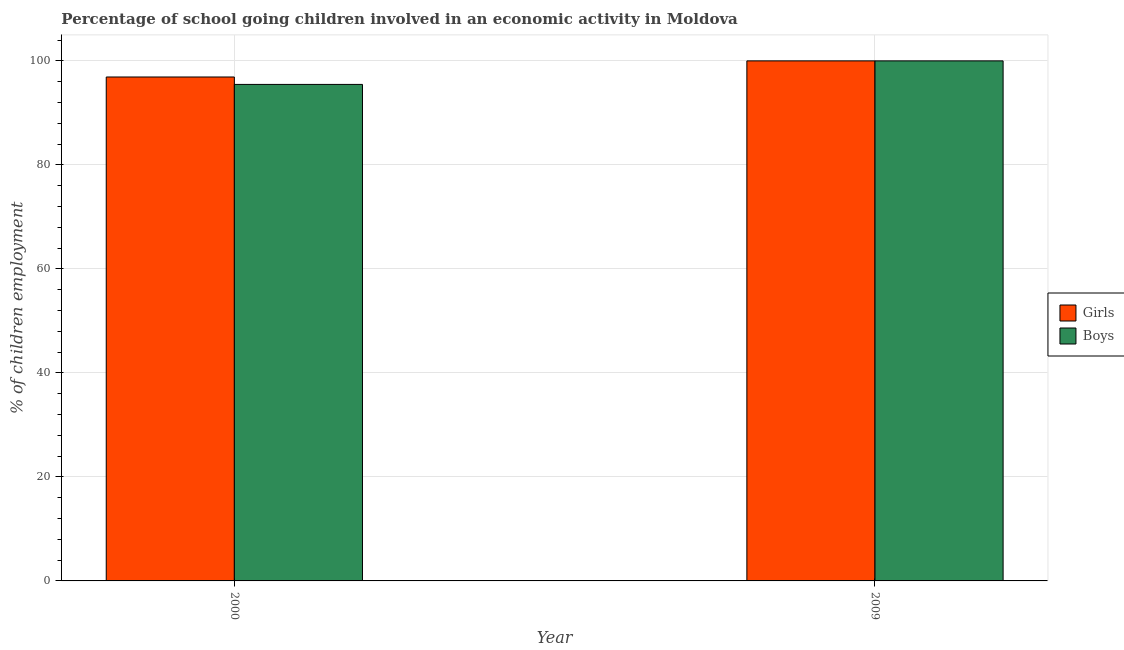How many groups of bars are there?
Make the answer very short. 2. Are the number of bars per tick equal to the number of legend labels?
Offer a very short reply. Yes. How many bars are there on the 1st tick from the left?
Your answer should be compact. 2. In how many cases, is the number of bars for a given year not equal to the number of legend labels?
Make the answer very short. 0. What is the percentage of school going boys in 2000?
Provide a succinct answer. 95.47. Across all years, what is the minimum percentage of school going boys?
Provide a succinct answer. 95.47. What is the total percentage of school going girls in the graph?
Keep it short and to the point. 196.9. What is the difference between the percentage of school going boys in 2000 and that in 2009?
Your answer should be very brief. -4.53. What is the difference between the percentage of school going girls in 2009 and the percentage of school going boys in 2000?
Your response must be concise. 3.1. What is the average percentage of school going girls per year?
Provide a short and direct response. 98.45. What is the ratio of the percentage of school going boys in 2000 to that in 2009?
Your answer should be very brief. 0.95. What does the 2nd bar from the left in 2000 represents?
Offer a very short reply. Boys. What does the 2nd bar from the right in 2000 represents?
Provide a short and direct response. Girls. Are all the bars in the graph horizontal?
Your answer should be very brief. No. What is the difference between two consecutive major ticks on the Y-axis?
Provide a short and direct response. 20. Are the values on the major ticks of Y-axis written in scientific E-notation?
Offer a terse response. No. Does the graph contain any zero values?
Make the answer very short. No. Does the graph contain grids?
Make the answer very short. Yes. Where does the legend appear in the graph?
Make the answer very short. Center right. How many legend labels are there?
Keep it short and to the point. 2. What is the title of the graph?
Keep it short and to the point. Percentage of school going children involved in an economic activity in Moldova. Does "Banks" appear as one of the legend labels in the graph?
Make the answer very short. No. What is the label or title of the X-axis?
Provide a succinct answer. Year. What is the label or title of the Y-axis?
Provide a short and direct response. % of children employment. What is the % of children employment of Girls in 2000?
Your answer should be compact. 96.9. What is the % of children employment of Boys in 2000?
Keep it short and to the point. 95.47. What is the % of children employment in Girls in 2009?
Offer a very short reply. 100. What is the % of children employment of Boys in 2009?
Provide a succinct answer. 100. Across all years, what is the maximum % of children employment in Girls?
Provide a short and direct response. 100. Across all years, what is the minimum % of children employment in Girls?
Your answer should be very brief. 96.9. Across all years, what is the minimum % of children employment of Boys?
Your answer should be compact. 95.47. What is the total % of children employment in Girls in the graph?
Offer a very short reply. 196.9. What is the total % of children employment in Boys in the graph?
Your response must be concise. 195.47. What is the difference between the % of children employment of Girls in 2000 and that in 2009?
Offer a very short reply. -3.1. What is the difference between the % of children employment in Boys in 2000 and that in 2009?
Provide a succinct answer. -4.53. What is the difference between the % of children employment of Girls in 2000 and the % of children employment of Boys in 2009?
Provide a short and direct response. -3.1. What is the average % of children employment of Girls per year?
Provide a succinct answer. 98.45. What is the average % of children employment of Boys per year?
Your response must be concise. 97.74. In the year 2000, what is the difference between the % of children employment of Girls and % of children employment of Boys?
Offer a very short reply. 1.43. In the year 2009, what is the difference between the % of children employment in Girls and % of children employment in Boys?
Provide a short and direct response. 0. What is the ratio of the % of children employment in Girls in 2000 to that in 2009?
Offer a very short reply. 0.97. What is the ratio of the % of children employment in Boys in 2000 to that in 2009?
Your response must be concise. 0.95. What is the difference between the highest and the second highest % of children employment of Girls?
Your answer should be very brief. 3.1. What is the difference between the highest and the second highest % of children employment in Boys?
Make the answer very short. 4.53. What is the difference between the highest and the lowest % of children employment of Girls?
Ensure brevity in your answer.  3.1. What is the difference between the highest and the lowest % of children employment of Boys?
Your response must be concise. 4.53. 